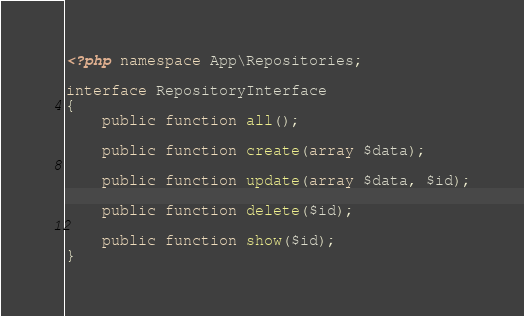<code> <loc_0><loc_0><loc_500><loc_500><_PHP_><?php namespace App\Repositories;

interface RepositoryInterface
{
    public function all();

    public function create(array $data);

    public function update(array $data, $id);

    public function delete($id);

    public function show($id);
}</code> 